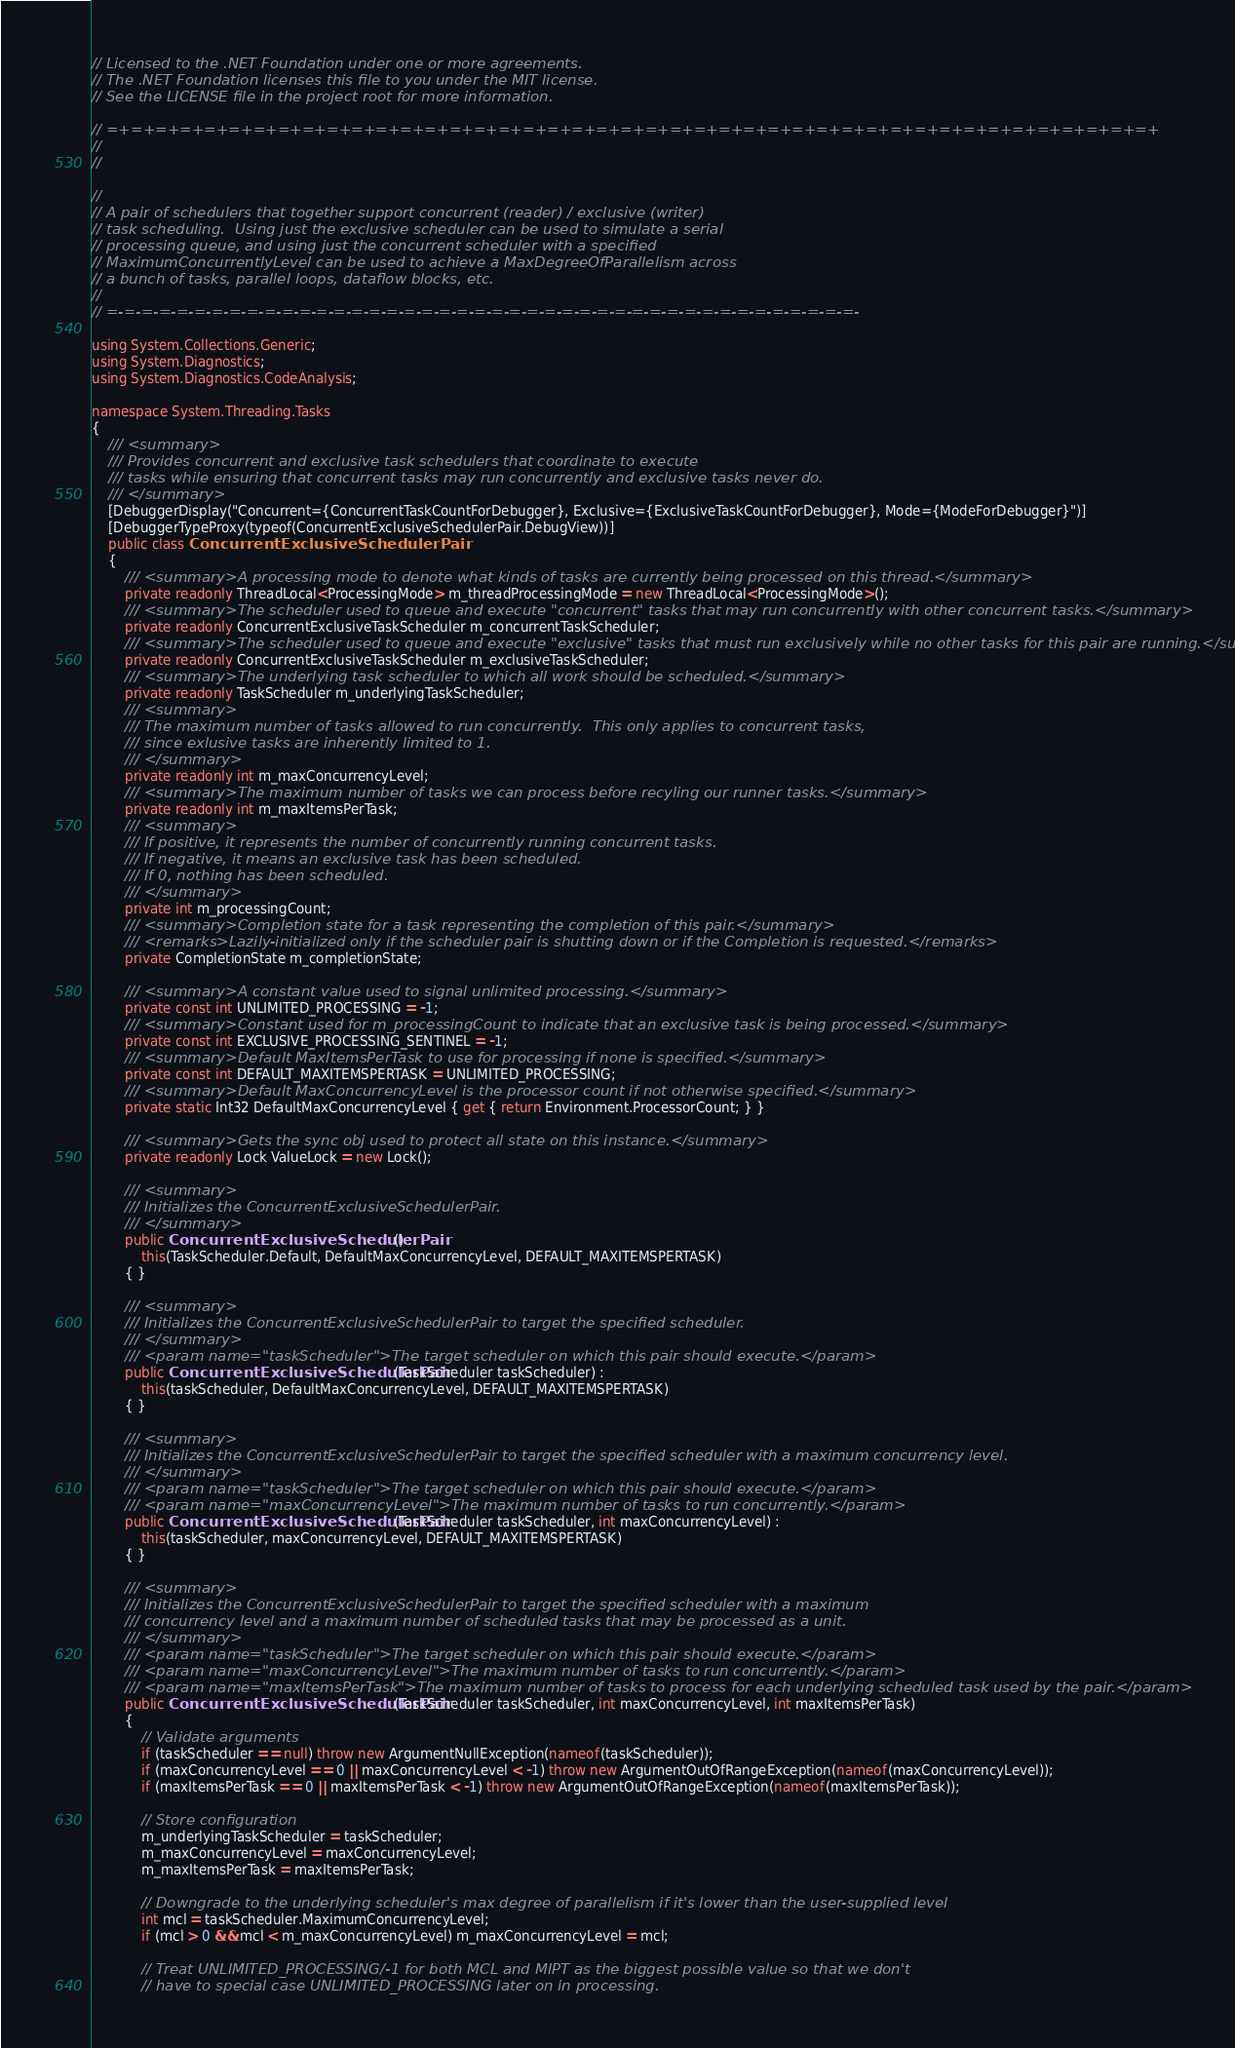Convert code to text. <code><loc_0><loc_0><loc_500><loc_500><_C#_>// Licensed to the .NET Foundation under one or more agreements.
// The .NET Foundation licenses this file to you under the MIT license.
// See the LICENSE file in the project root for more information.

// =+=+=+=+=+=+=+=+=+=+=+=+=+=+=+=+=+=+=+=+=+=+=+=+=+=+=+=+=+=+=+=+=+=+=+=+=+=+=+=+=+=+=+
//
//

//
// A pair of schedulers that together support concurrent (reader) / exclusive (writer) 
// task scheduling.  Using just the exclusive scheduler can be used to simulate a serial
// processing queue, and using just the concurrent scheduler with a specified 
// MaximumConcurrentlyLevel can be used to achieve a MaxDegreeOfParallelism across
// a bunch of tasks, parallel loops, dataflow blocks, etc.
//
// =-=-=-=-=-=-=-=-=-=-=-=-=-=-=-=-=-=-=-=-=-=-=-=-=-=-=-=-=-=-=-=-=-=-=-=-=-=-=-=-=-=-=-

using System.Collections.Generic;
using System.Diagnostics;
using System.Diagnostics.CodeAnalysis;

namespace System.Threading.Tasks
{
    /// <summary>
    /// Provides concurrent and exclusive task schedulers that coordinate to execute
    /// tasks while ensuring that concurrent tasks may run concurrently and exclusive tasks never do.
    /// </summary>
    [DebuggerDisplay("Concurrent={ConcurrentTaskCountForDebugger}, Exclusive={ExclusiveTaskCountForDebugger}, Mode={ModeForDebugger}")]
    [DebuggerTypeProxy(typeof(ConcurrentExclusiveSchedulerPair.DebugView))]
    public class ConcurrentExclusiveSchedulerPair
    {
        /// <summary>A processing mode to denote what kinds of tasks are currently being processed on this thread.</summary>
        private readonly ThreadLocal<ProcessingMode> m_threadProcessingMode = new ThreadLocal<ProcessingMode>();
        /// <summary>The scheduler used to queue and execute "concurrent" tasks that may run concurrently with other concurrent tasks.</summary>
        private readonly ConcurrentExclusiveTaskScheduler m_concurrentTaskScheduler;
        /// <summary>The scheduler used to queue and execute "exclusive" tasks that must run exclusively while no other tasks for this pair are running.</summary>
        private readonly ConcurrentExclusiveTaskScheduler m_exclusiveTaskScheduler;
        /// <summary>The underlying task scheduler to which all work should be scheduled.</summary>
        private readonly TaskScheduler m_underlyingTaskScheduler;
        /// <summary>
        /// The maximum number of tasks allowed to run concurrently.  This only applies to concurrent tasks, 
        /// since exlusive tasks are inherently limited to 1.
        /// </summary>
        private readonly int m_maxConcurrencyLevel;
        /// <summary>The maximum number of tasks we can process before recyling our runner tasks.</summary>
        private readonly int m_maxItemsPerTask;
        /// <summary>
        /// If positive, it represents the number of concurrently running concurrent tasks.
        /// If negative, it means an exclusive task has been scheduled.
        /// If 0, nothing has been scheduled.
        /// </summary>
        private int m_processingCount;
        /// <summary>Completion state for a task representing the completion of this pair.</summary>
        /// <remarks>Lazily-initialized only if the scheduler pair is shutting down or if the Completion is requested.</remarks>
        private CompletionState m_completionState;

        /// <summary>A constant value used to signal unlimited processing.</summary>
        private const int UNLIMITED_PROCESSING = -1;
        /// <summary>Constant used for m_processingCount to indicate that an exclusive task is being processed.</summary>
        private const int EXCLUSIVE_PROCESSING_SENTINEL = -1;
        /// <summary>Default MaxItemsPerTask to use for processing if none is specified.</summary>
        private const int DEFAULT_MAXITEMSPERTASK = UNLIMITED_PROCESSING;
        /// <summary>Default MaxConcurrencyLevel is the processor count if not otherwise specified.</summary>
        private static Int32 DefaultMaxConcurrencyLevel { get { return Environment.ProcessorCount; } }

        /// <summary>Gets the sync obj used to protect all state on this instance.</summary>
        private readonly Lock ValueLock = new Lock();

        /// <summary>
        /// Initializes the ConcurrentExclusiveSchedulerPair.
        /// </summary>
        public ConcurrentExclusiveSchedulerPair() :
            this(TaskScheduler.Default, DefaultMaxConcurrencyLevel, DEFAULT_MAXITEMSPERTASK)
        { }

        /// <summary>
        /// Initializes the ConcurrentExclusiveSchedulerPair to target the specified scheduler.
        /// </summary>
        /// <param name="taskScheduler">The target scheduler on which this pair should execute.</param>
        public ConcurrentExclusiveSchedulerPair(TaskScheduler taskScheduler) :
            this(taskScheduler, DefaultMaxConcurrencyLevel, DEFAULT_MAXITEMSPERTASK)
        { }

        /// <summary>
        /// Initializes the ConcurrentExclusiveSchedulerPair to target the specified scheduler with a maximum concurrency level.
        /// </summary>
        /// <param name="taskScheduler">The target scheduler on which this pair should execute.</param>
        /// <param name="maxConcurrencyLevel">The maximum number of tasks to run concurrently.</param>
        public ConcurrentExclusiveSchedulerPair(TaskScheduler taskScheduler, int maxConcurrencyLevel) :
            this(taskScheduler, maxConcurrencyLevel, DEFAULT_MAXITEMSPERTASK)
        { }

        /// <summary>
        /// Initializes the ConcurrentExclusiveSchedulerPair to target the specified scheduler with a maximum 
        /// concurrency level and a maximum number of scheduled tasks that may be processed as a unit.
        /// </summary>
        /// <param name="taskScheduler">The target scheduler on which this pair should execute.</param>
        /// <param name="maxConcurrencyLevel">The maximum number of tasks to run concurrently.</param>
        /// <param name="maxItemsPerTask">The maximum number of tasks to process for each underlying scheduled task used by the pair.</param>
        public ConcurrentExclusiveSchedulerPair(TaskScheduler taskScheduler, int maxConcurrencyLevel, int maxItemsPerTask)
        {
            // Validate arguments
            if (taskScheduler == null) throw new ArgumentNullException(nameof(taskScheduler));
            if (maxConcurrencyLevel == 0 || maxConcurrencyLevel < -1) throw new ArgumentOutOfRangeException(nameof(maxConcurrencyLevel));
            if (maxItemsPerTask == 0 || maxItemsPerTask < -1) throw new ArgumentOutOfRangeException(nameof(maxItemsPerTask));

            // Store configuration
            m_underlyingTaskScheduler = taskScheduler;
            m_maxConcurrencyLevel = maxConcurrencyLevel;
            m_maxItemsPerTask = maxItemsPerTask;

            // Downgrade to the underlying scheduler's max degree of parallelism if it's lower than the user-supplied level
            int mcl = taskScheduler.MaximumConcurrencyLevel;
            if (mcl > 0 && mcl < m_maxConcurrencyLevel) m_maxConcurrencyLevel = mcl;

            // Treat UNLIMITED_PROCESSING/-1 for both MCL and MIPT as the biggest possible value so that we don't
            // have to special case UNLIMITED_PROCESSING later on in processing.</code> 